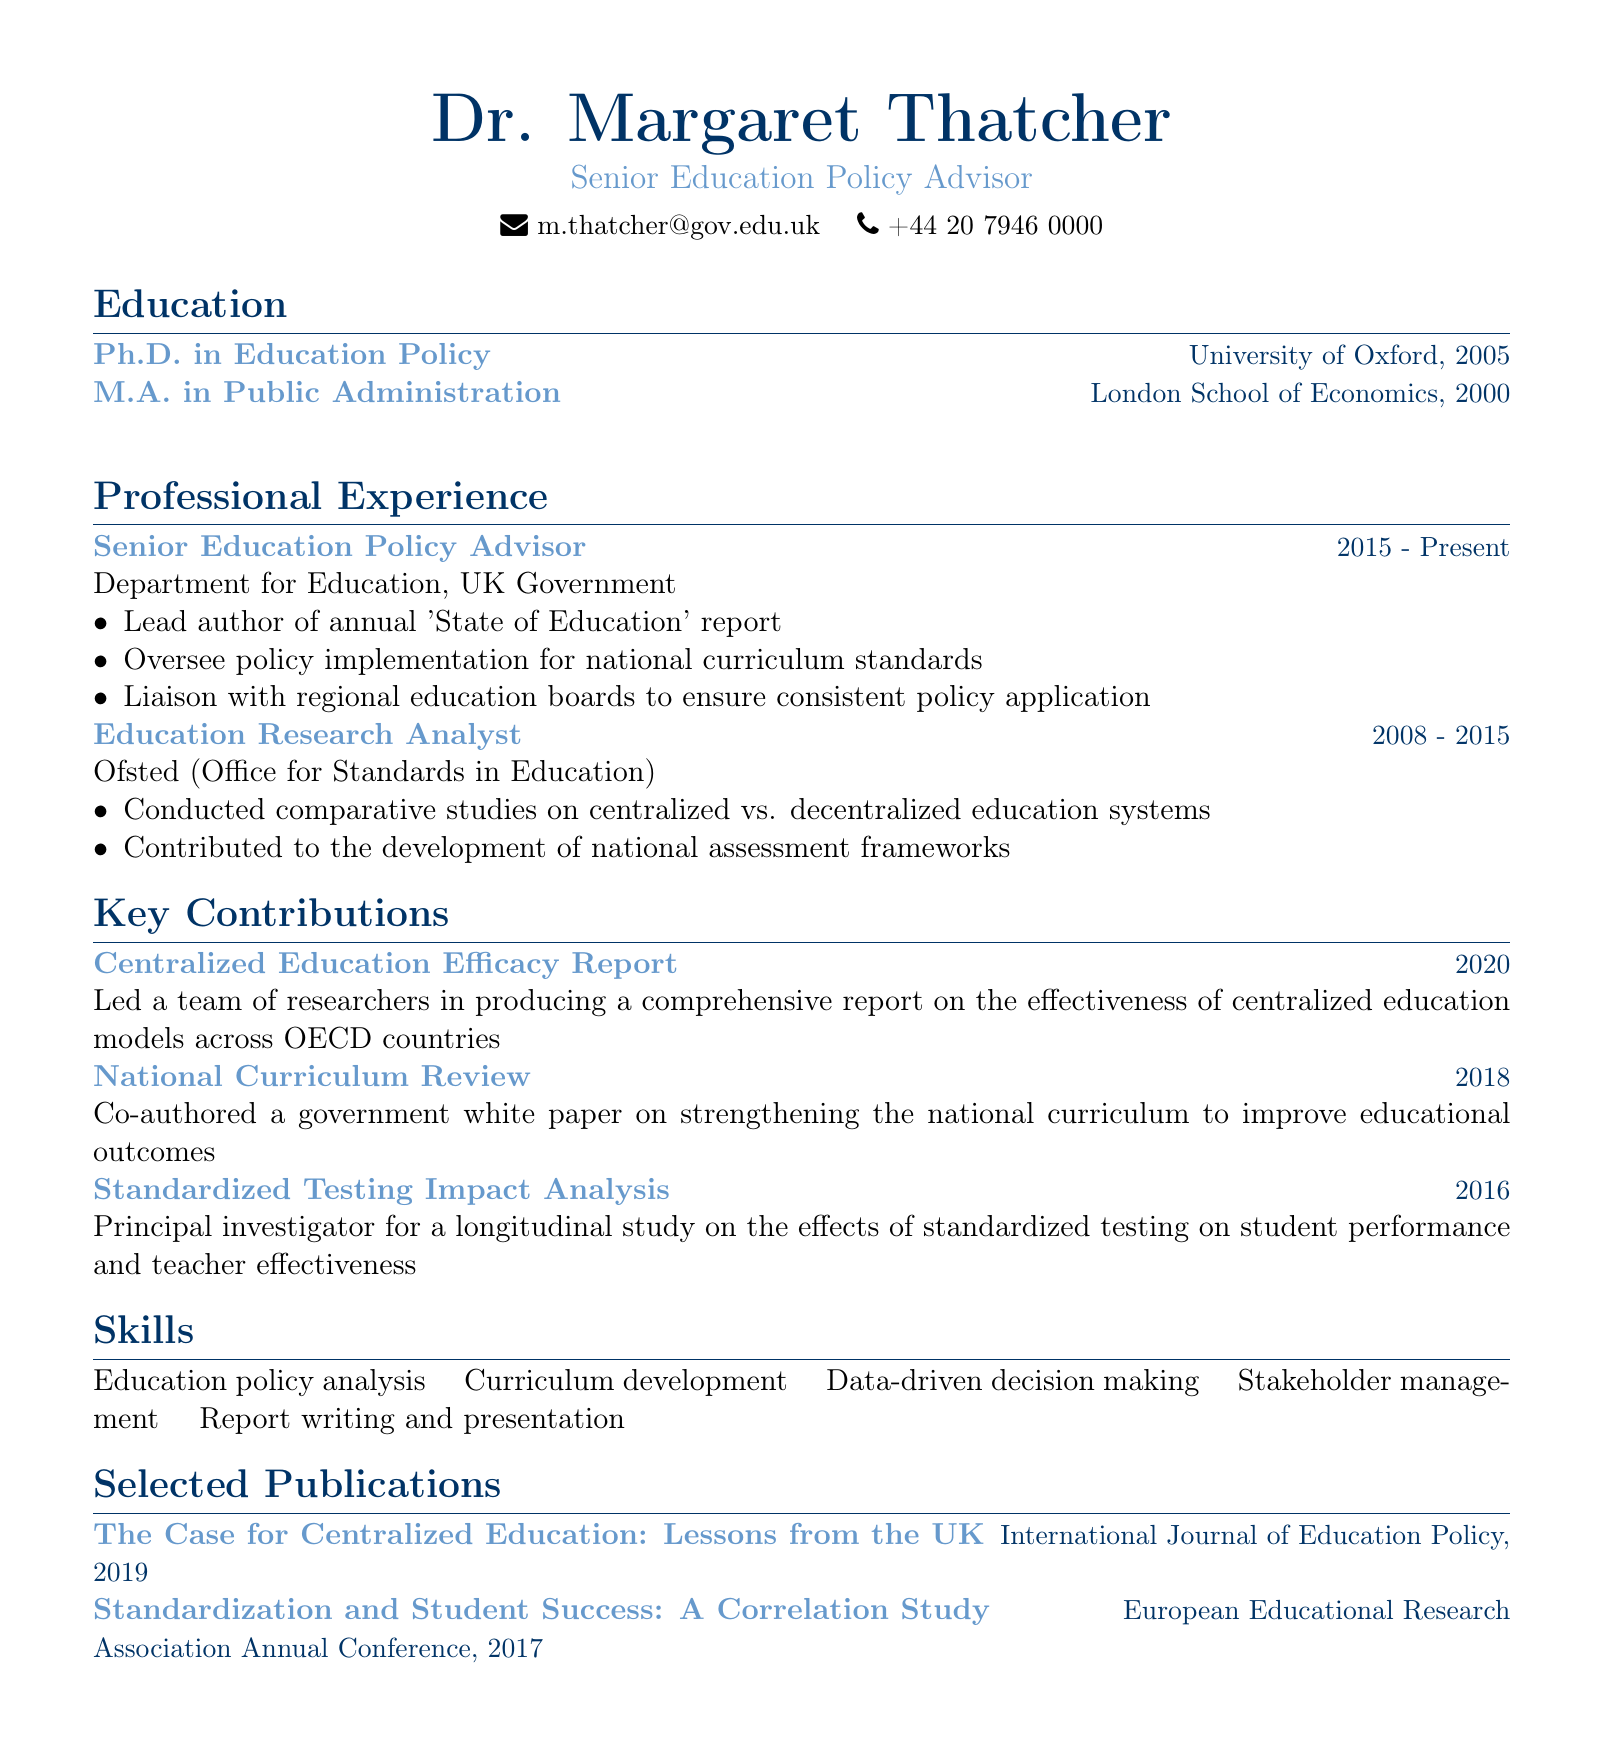What is Dr. Thatcher's title? The title is listed in the personal information section of the document.
Answer: Senior Education Policy Advisor Which university did Dr. Thatcher obtain her Ph.D. from? The document states the institution where Dr. Thatcher received her Ph.D.
Answer: University of Oxford In what year did Dr. Thatcher start working as a Senior Education Policy Advisor? The duration of the position provides the starting year.
Answer: 2015 How many years did Dr. Thatcher work as an Education Research Analyst? By comparing the starting and ending years of the position, we can calculate the duration.
Answer: 7 years What was the title of the key contribution made in 2020? The document includes a list of key contributions with their titles and years.
Answer: Centralized Education Efficacy Report What is one of Dr. Thatcher’s skills? The skills section lists several relevant skills for her professional role.
Answer: Education policy analysis What type of publication is "The Case for Centralized Education: Lessons from the UK"? This question asks for the type of source where this publication is found.
Answer: Journal How many key contributions are listed in the document? The number of key contributions is simply the count presented in the document.
Answer: 3 What is the phone number provided for Dr. Thatcher? The contact information section contains Dr. Thatcher's phone number.
Answer: +44 20 7946 0000 What is the subject of the 2016 study led by Dr. Thatcher? The title of the contribution in the document specifies the focus of that study.
Answer: Standardized Testing Impact Analysis 